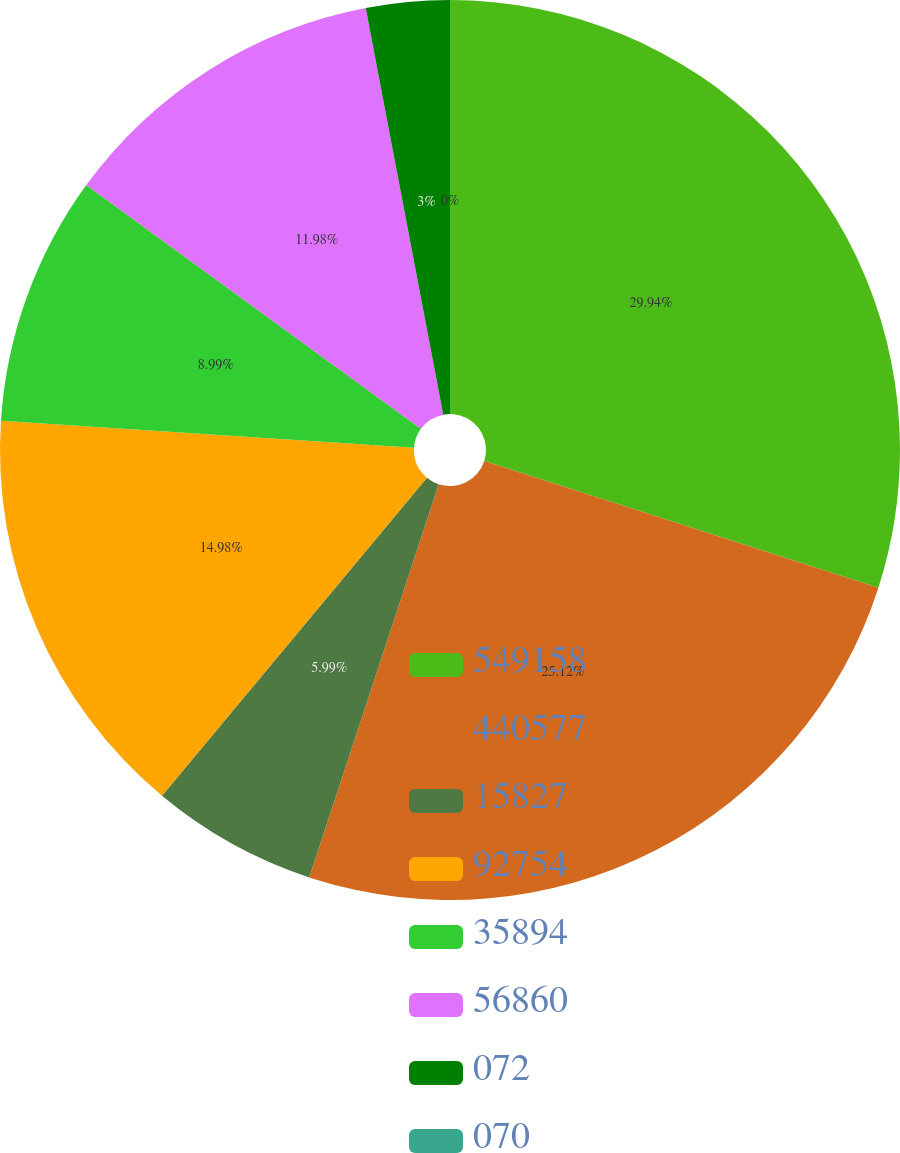Convert chart. <chart><loc_0><loc_0><loc_500><loc_500><pie_chart><fcel>549158<fcel>440577<fcel>15827<fcel>92754<fcel>35894<fcel>56860<fcel>072<fcel>070<nl><fcel>29.95%<fcel>25.12%<fcel>5.99%<fcel>14.98%<fcel>8.99%<fcel>11.98%<fcel>3.0%<fcel>0.0%<nl></chart> 